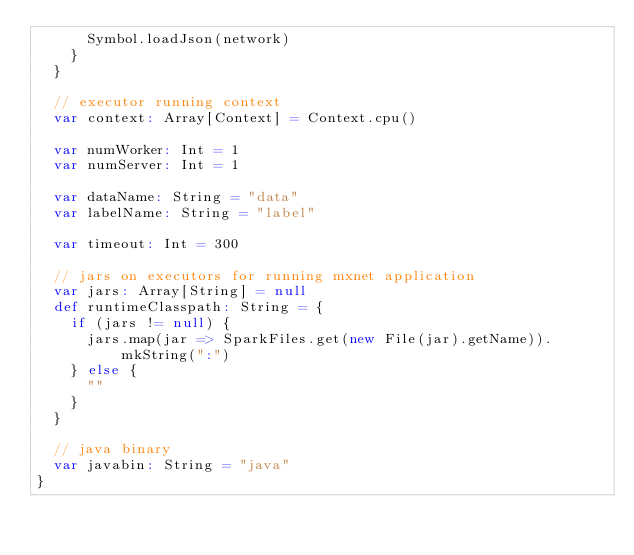Convert code to text. <code><loc_0><loc_0><loc_500><loc_500><_Scala_>      Symbol.loadJson(network)
    }
  }

  // executor running context
  var context: Array[Context] = Context.cpu()

  var numWorker: Int = 1
  var numServer: Int = 1

  var dataName: String = "data"
  var labelName: String = "label"

  var timeout: Int = 300

  // jars on executors for running mxnet application
  var jars: Array[String] = null
  def runtimeClasspath: String = {
    if (jars != null) {
      jars.map(jar => SparkFiles.get(new File(jar).getName)).mkString(":")
    } else {
      ""
    }
  }

  // java binary
  var javabin: String = "java"
}
</code> 